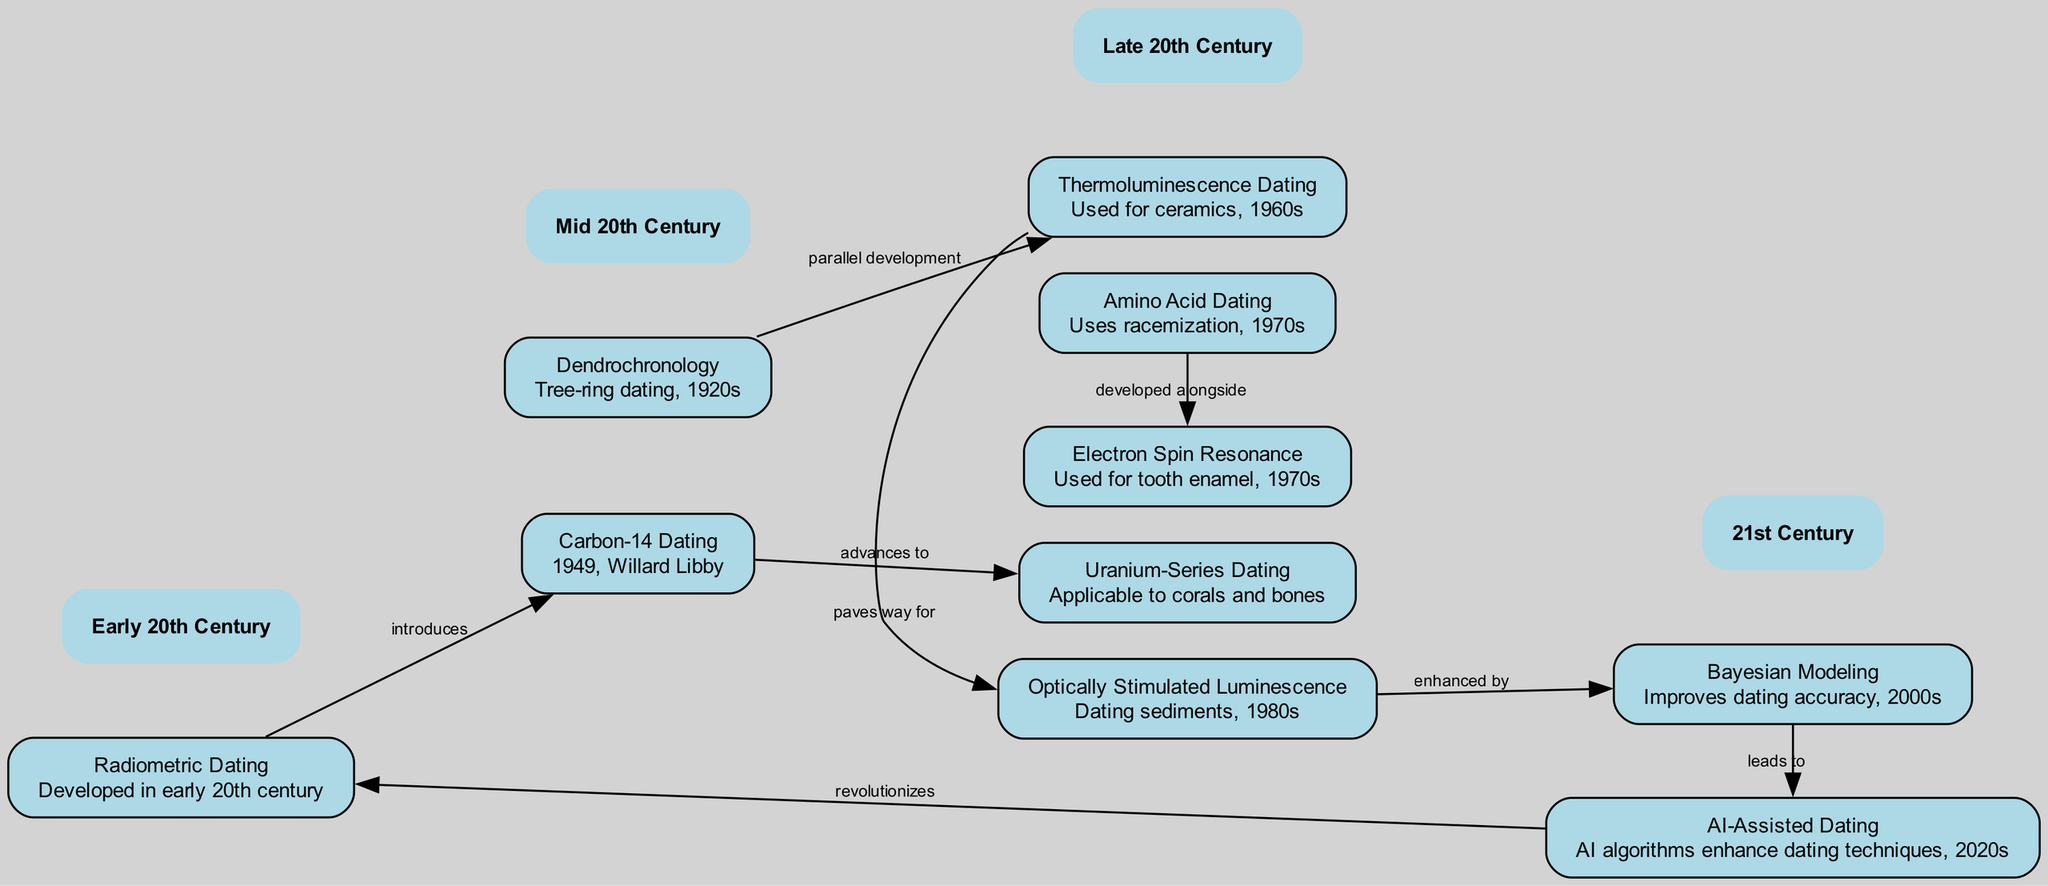What technique was developed in the early 20th century? The diagram indicates that "Radiometric Dating" was developed in the early 20th century, as noted by the description associated with that node.
Answer: Radiometric Dating Which dating technique was introduced by Radiometric Dating? The edge labeled "introduces" from "Radiometric Dating" to "Carbon-14 Dating" shows that Carbon-14 Dating was introduced by Radiometric Dating.
Answer: Carbon-14 Dating How many dating techniques are mentioned in the diagram? By counting the nodes listed in the diagram, there are 10 distinct dating techniques featured.
Answer: 10 What decade was Thermoluminescence Dating used in? The description for "Thermoluminescence Dating" states that it was used in the 1960s, thus providing the decade when this technique was actively utilized.
Answer: 1960s What relationship is indicated between Bayesian Modeling and AI-Assisted Dating? The diagram shows a directed edge from "Bayesian Modeling" to "AI-Assisted Dating" labeled "leads to," indicating that Bayesian Modeling leads to the development of AI-Assisted Dating techniques.
Answer: leads to Which dating method is enhanced by Optically Stimulated Luminescence? The diagram specifies that "Bayesian Modeling" is enhanced by "Optically Stimulated Luminescence," suggesting a direct improvement in dating accuracy from this connection.
Answer: Bayesian Modeling Which two dating methods were developed alongside each other? The edge labeled "developed alongside" shows that "Amino Acid Dating" and "Electron Spin Resonance" were developed alongside each other during the 1970s, as seen in their proximity in the diagram.
Answer: Amino Acid Dating and Electron Spin Resonance What is the overall trend in dating techniques from the early 20th century to the 2020s? Analyzing the flow from "Radiometric Dating" to "AI-Assisted Dating," the trend shows a progression and modernization of dating techniques over time that increasingly incorporates technology.
Answer: Increasing modernization What is the significance of AI-Assisted Dating in the timeline? The description for "AI-Assisted Dating" indicates that it revolutionizes traditional dating methods, marking a significant advancement in the 2020s as indicated by the directed edge back to "Radiometric Dating."
Answer: revolutionizes 